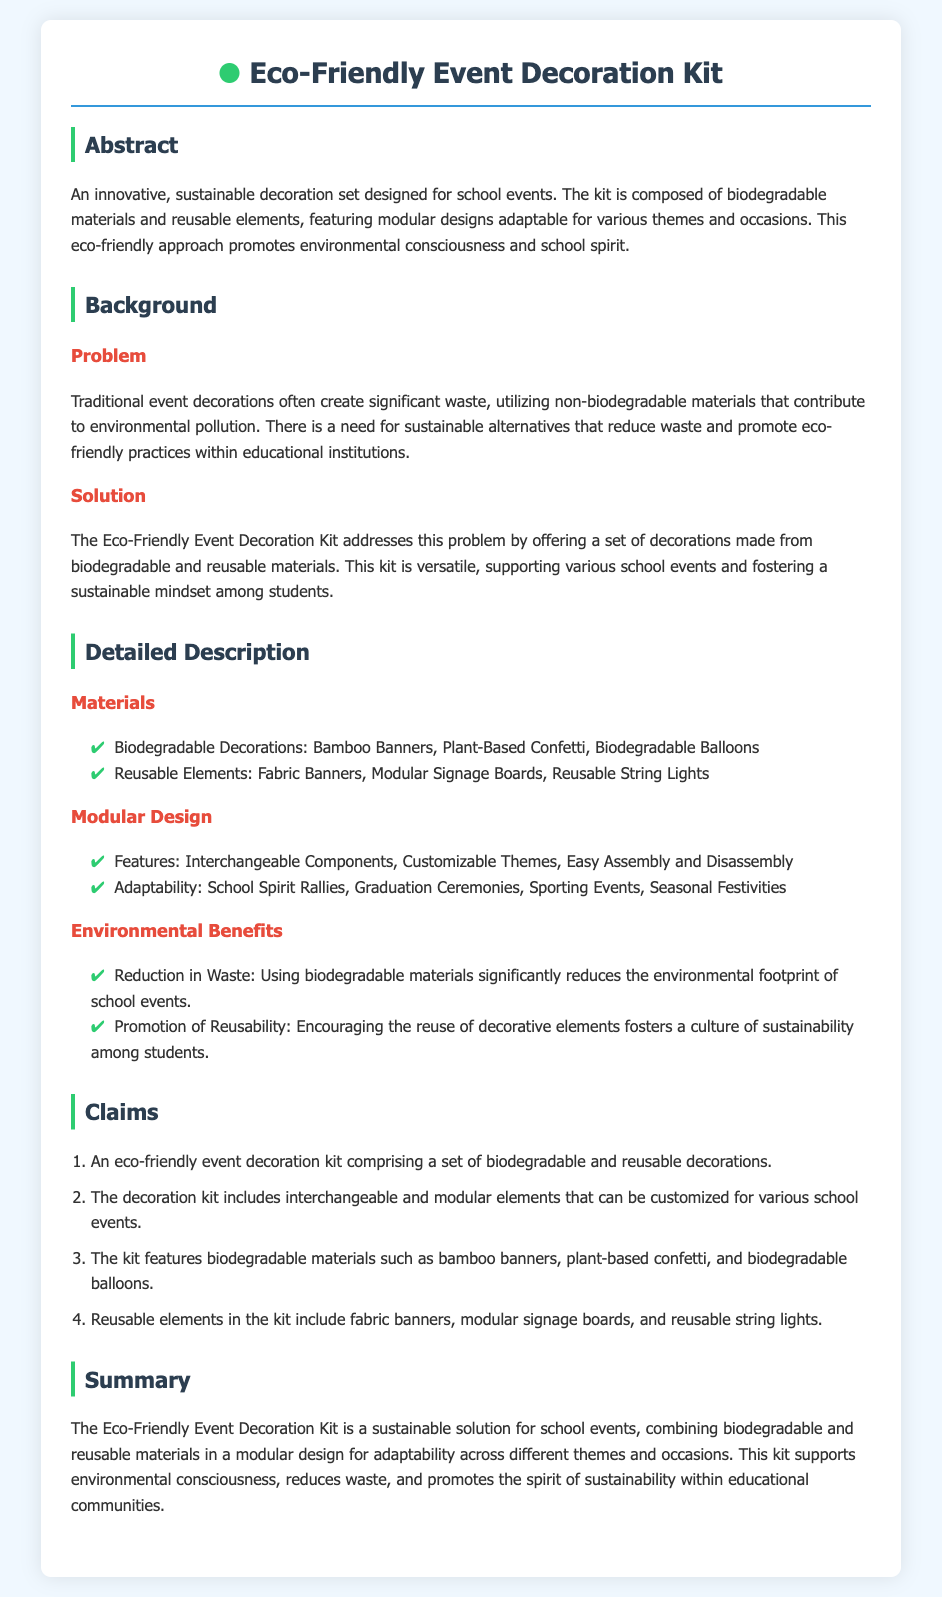What materials are used in biodegradable decorations? The specific materials mentioned for biodegradable decorations are bamboo banners, plant-based confetti, and biodegradable balloons.
Answer: Bamboo banners, plant-based confetti, biodegradable balloons What is the main problem the Eco-Friendly Event Decoration Kit addresses? The main problem is the significant waste created by traditional event decorations that utilize non-biodegradable materials, contributing to environmental pollution.
Answer: Significant waste How many claims are made in the patent application? The document lists a total of four claims regarding the decoration kit.
Answer: Four What type of events can the decoration kit be used for? The kit is adaptable for various events such as school spirit rallies, graduation ceremonies, sporting events, and seasonal festivities.
Answer: School spirit rallies, graduation ceremonies, sporting events, seasonal festivities What is a key environmental benefit of using this decoration kit? One key benefit is the reduction in waste through the usage of biodegradable materials, which significantly reduces the environmental footprint of school events.
Answer: Reduction in waste What does the modular design feature include? The modular design features interchangeable components, customizable themes, and easy assembly and disassembly.
Answer: Interchangeable components, customizable themes, easy assembly What promotes environmental consciousness within educational institutions? The Eco-Friendly Event Decoration Kit promotes environmental consciousness by offering a sustainable alternative to traditional school event decorations.
Answer: Offering a sustainable alternative 